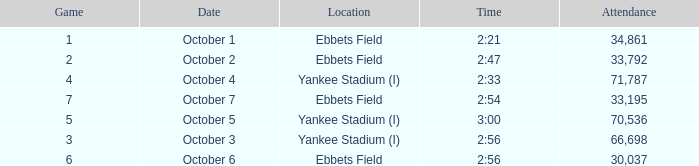Date of October 1 has what average game? 1.0. I'm looking to parse the entire table for insights. Could you assist me with that? {'header': ['Game', 'Date', 'Location', 'Time', 'Attendance'], 'rows': [['1', 'October 1', 'Ebbets Field', '2:21', '34,861'], ['2', 'October 2', 'Ebbets Field', '2:47', '33,792'], ['4', 'October 4', 'Yankee Stadium (I)', '2:33', '71,787'], ['7', 'October 7', 'Ebbets Field', '2:54', '33,195'], ['5', 'October 5', 'Yankee Stadium (I)', '3:00', '70,536'], ['3', 'October 3', 'Yankee Stadium (I)', '2:56', '66,698'], ['6', 'October 6', 'Ebbets Field', '2:56', '30,037']]} 